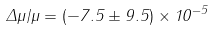Convert formula to latex. <formula><loc_0><loc_0><loc_500><loc_500>\Delta \mu / \mu = ( - 7 . 5 \pm 9 . 5 ) \times 1 0 ^ { - 5 }</formula> 